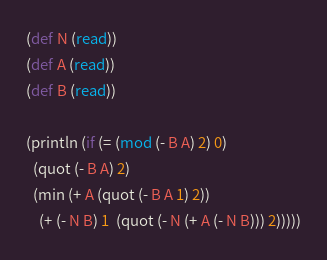<code> <loc_0><loc_0><loc_500><loc_500><_Clojure_>(def N (read))
(def A (read))
(def B (read))

(println (if (= (mod (- B A) 2) 0) 
  (quot (- B A) 2)
  (min (+ A (quot (- B A 1) 2)) 
    (+ (- N B) 1  (quot (- N (+ A (- N B))) 2)))))</code> 